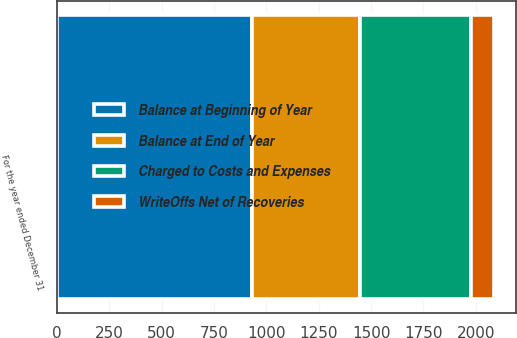<chart> <loc_0><loc_0><loc_500><loc_500><stacked_bar_chart><ecel><fcel>For the year ended December 31<nl><fcel>Charged to Costs and Expenses<fcel>527<nl><fcel>Balance at End of Year<fcel>516<nl><fcel>WriteOffs Net of Recoveries<fcel>110<nl><fcel>Balance at Beginning of Year<fcel>933<nl></chart> 